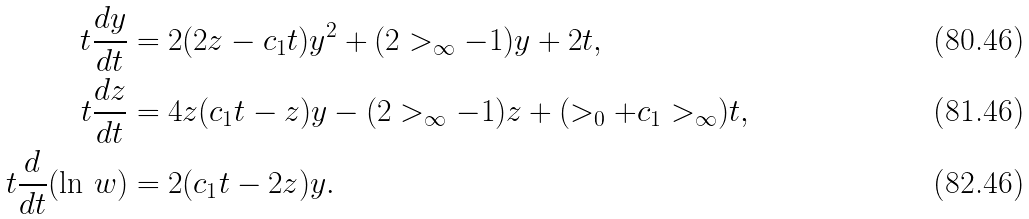<formula> <loc_0><loc_0><loc_500><loc_500>t \frac { d y } { d t } & = 2 ( 2 z - c _ { 1 } t ) y ^ { 2 } + ( 2 > _ { \infty } - 1 ) y + 2 t , \\ t \frac { d z } { d t } & = 4 z ( c _ { 1 } t - z ) y - ( 2 > _ { \infty } - 1 ) z + ( > _ { 0 } + c _ { 1 } > _ { \infty } ) t , \\ t \frac { d } { d t } ( \ln \, w ) & = 2 ( c _ { 1 } t - 2 z ) y .</formula> 